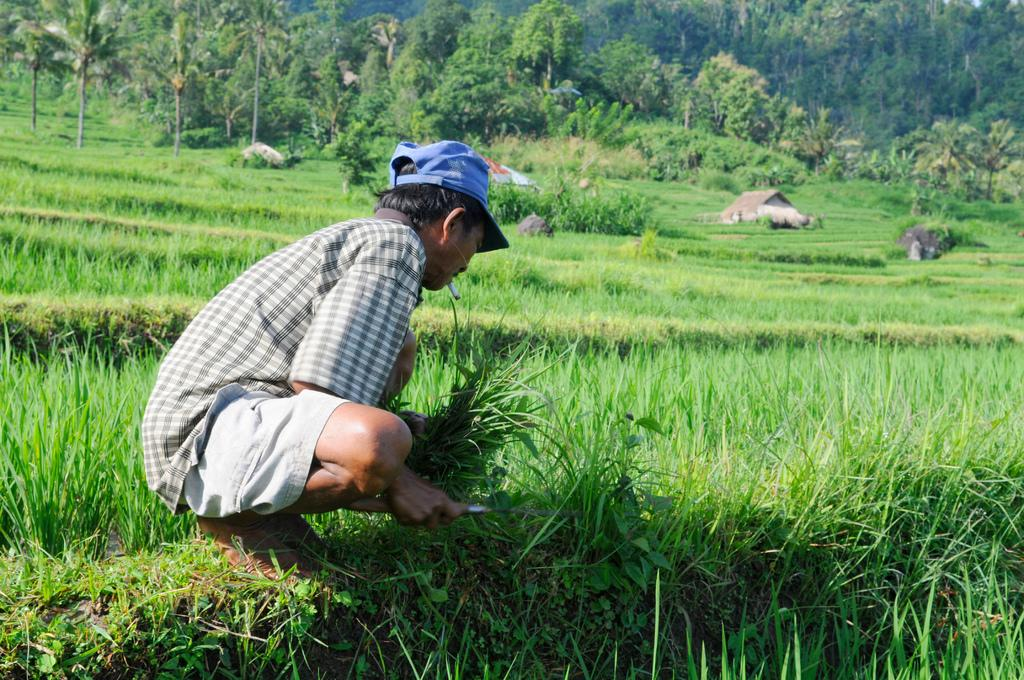What can be seen in the image? There is a person in the image. What is the person holding in their hand? The person is holding an object in their hand. What type of terrain is visible in the image? Grass is visible on the ground. What structures can be seen in the background of the image? There is a house and trees in the background of the image. What type of butter is being used to perform magic on the faucet in the image? There is no butter, magic, or faucet present in the image. 